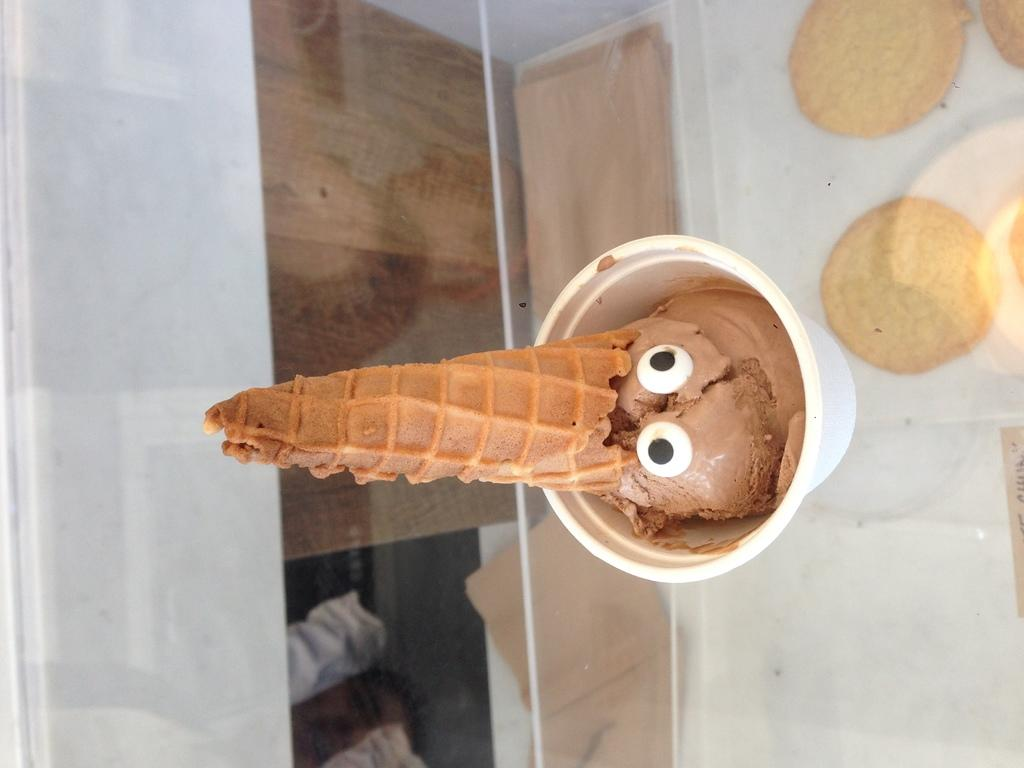What type of dessert is featured in the image? There is an ice cream cup and a cone in the image. Where are the ice cream cup and cone located? The ice cream cup and cone are on a table. What other food items can be seen in the image? There are biscuits in the background of the image. How many spiders are crawling on the ice cream cone in the image? There are no spiders present in the image; it features an ice cream cup and cone with biscuits in the background. What time is displayed on the clock in the image? There is no clock present in the image. 